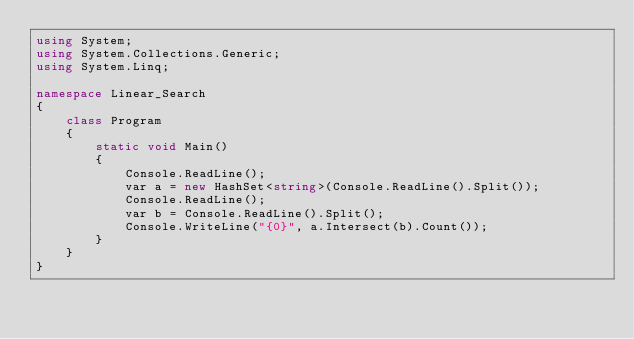<code> <loc_0><loc_0><loc_500><loc_500><_C#_>using System;
using System.Collections.Generic;
using System.Linq;
 
namespace Linear_Search
{
    class Program
    {
        static void Main()
        {
            Console.ReadLine();
            var a = new HashSet<string>(Console.ReadLine().Split());
            Console.ReadLine();
            var b = Console.ReadLine().Split();
            Console.WriteLine("{0}", a.Intersect(b).Count());
        }
    }
}</code> 